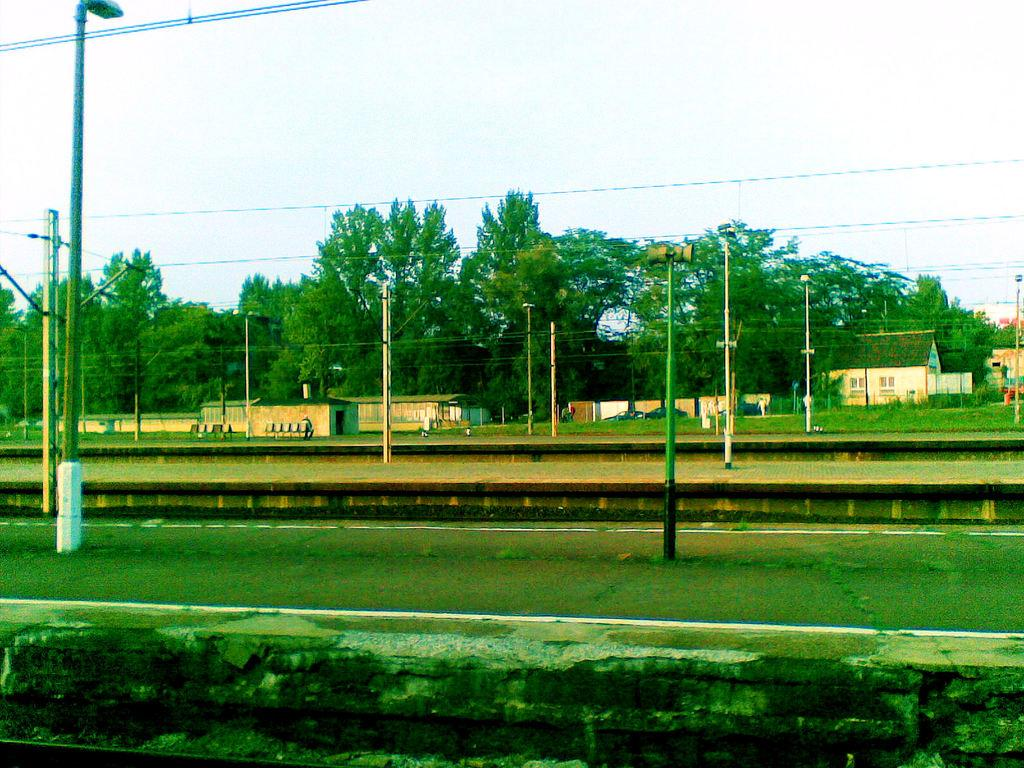What structures can be seen in the image? There are poles and wires in the image, as well as platforms in the middle. What can be found in the background of the image? In the background, there are sheds, trees, and the sky is visible. What type of jewel is hanging from the stick in the image? There is no jewel or stick present in the image. 